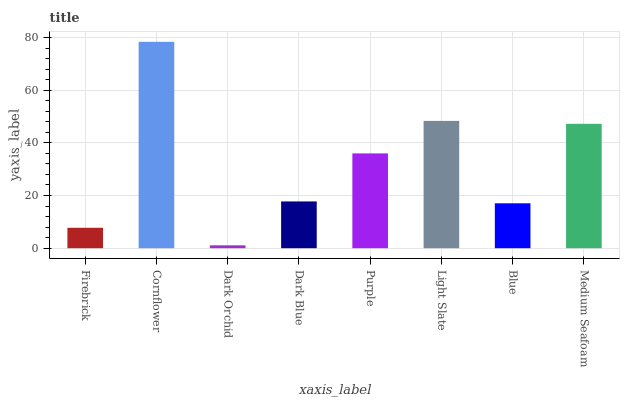Is Dark Orchid the minimum?
Answer yes or no. Yes. Is Cornflower the maximum?
Answer yes or no. Yes. Is Cornflower the minimum?
Answer yes or no. No. Is Dark Orchid the maximum?
Answer yes or no. No. Is Cornflower greater than Dark Orchid?
Answer yes or no. Yes. Is Dark Orchid less than Cornflower?
Answer yes or no. Yes. Is Dark Orchid greater than Cornflower?
Answer yes or no. No. Is Cornflower less than Dark Orchid?
Answer yes or no. No. Is Purple the high median?
Answer yes or no. Yes. Is Dark Blue the low median?
Answer yes or no. Yes. Is Dark Blue the high median?
Answer yes or no. No. Is Blue the low median?
Answer yes or no. No. 